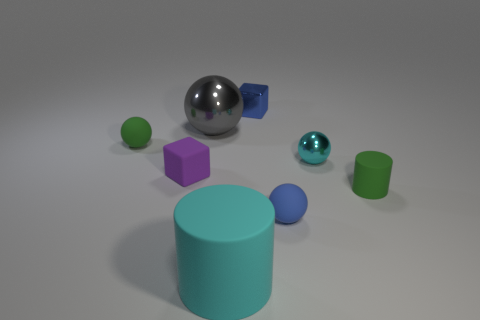What is the size of the ball that is the same color as the large cylinder?
Provide a short and direct response. Small. There is a cube that is left of the large cylinder; what is its material?
Your answer should be very brief. Rubber. Are there an equal number of small green rubber things that are behind the green ball and big rubber objects that are behind the big rubber object?
Ensure brevity in your answer.  Yes. There is a cube behind the big sphere; is it the same size as the block that is to the left of the big shiny thing?
Provide a short and direct response. Yes. How many rubber things have the same color as the large matte cylinder?
Your response must be concise. 0. What is the material of the tiny thing that is the same color as the large cylinder?
Your answer should be compact. Metal. Is the number of cylinders that are on the right side of the big matte cylinder greater than the number of large brown things?
Make the answer very short. Yes. Does the cyan shiny object have the same shape as the large gray metal object?
Your response must be concise. Yes. How many spheres have the same material as the large cyan thing?
Offer a terse response. 2. What size is the gray object that is the same shape as the blue matte object?
Your response must be concise. Large. 